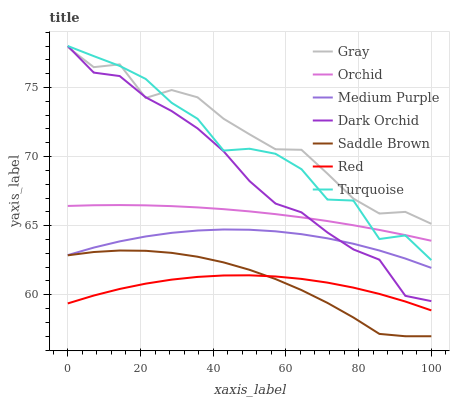Does Red have the minimum area under the curve?
Answer yes or no. Yes. Does Gray have the maximum area under the curve?
Answer yes or no. Yes. Does Turquoise have the minimum area under the curve?
Answer yes or no. No. Does Turquoise have the maximum area under the curve?
Answer yes or no. No. Is Orchid the smoothest?
Answer yes or no. Yes. Is Turquoise the roughest?
Answer yes or no. Yes. Is Dark Orchid the smoothest?
Answer yes or no. No. Is Dark Orchid the roughest?
Answer yes or no. No. Does Turquoise have the lowest value?
Answer yes or no. No. Does Medium Purple have the highest value?
Answer yes or no. No. Is Medium Purple less than Gray?
Answer yes or no. Yes. Is Gray greater than Orchid?
Answer yes or no. Yes. Does Medium Purple intersect Gray?
Answer yes or no. No. 